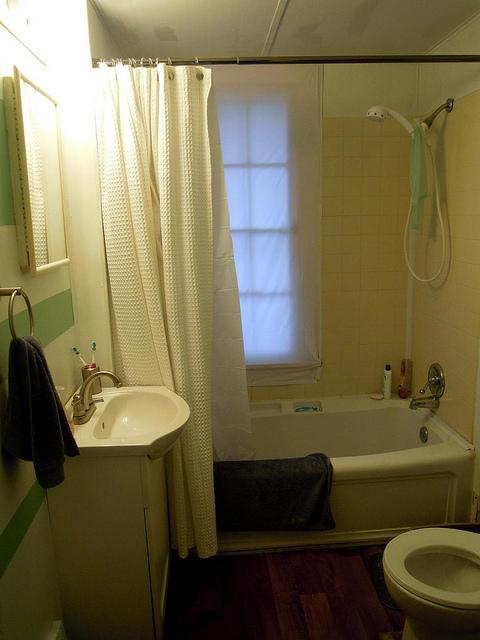What color are the stripes on the side of the bathroom wall? green 